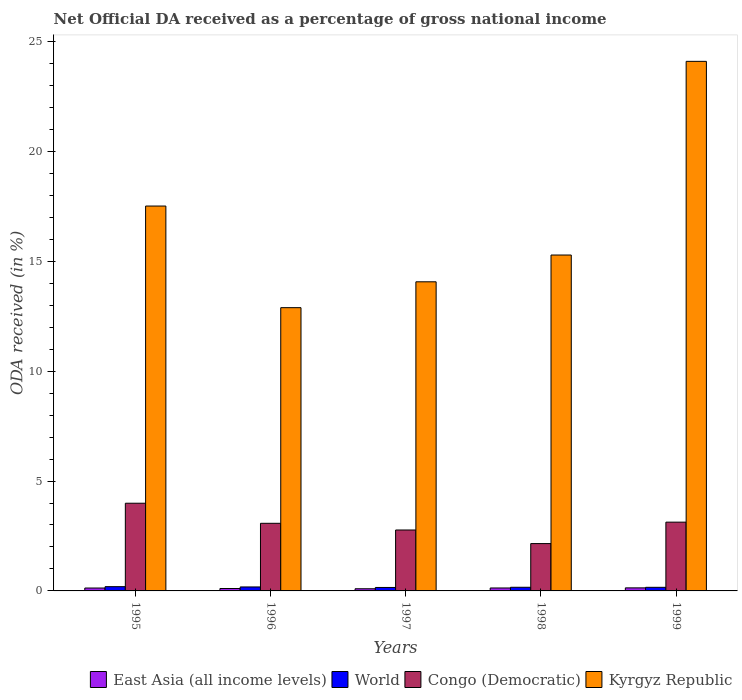How many different coloured bars are there?
Offer a terse response. 4. How many groups of bars are there?
Ensure brevity in your answer.  5. Are the number of bars per tick equal to the number of legend labels?
Your response must be concise. Yes. How many bars are there on the 4th tick from the right?
Offer a very short reply. 4. What is the label of the 3rd group of bars from the left?
Ensure brevity in your answer.  1997. In how many cases, is the number of bars for a given year not equal to the number of legend labels?
Give a very brief answer. 0. What is the net official DA received in Kyrgyz Republic in 1995?
Make the answer very short. 17.51. Across all years, what is the maximum net official DA received in Kyrgyz Republic?
Offer a very short reply. 24.09. Across all years, what is the minimum net official DA received in Congo (Democratic)?
Ensure brevity in your answer.  2.15. In which year was the net official DA received in Kyrgyz Republic maximum?
Provide a short and direct response. 1999. In which year was the net official DA received in Kyrgyz Republic minimum?
Make the answer very short. 1996. What is the total net official DA received in Kyrgyz Republic in the graph?
Offer a very short reply. 83.84. What is the difference between the net official DA received in Congo (Democratic) in 1995 and that in 1996?
Your answer should be compact. 0.91. What is the difference between the net official DA received in World in 1997 and the net official DA received in East Asia (all income levels) in 1999?
Offer a very short reply. 0.02. What is the average net official DA received in East Asia (all income levels) per year?
Your answer should be very brief. 0.12. In the year 1995, what is the difference between the net official DA received in World and net official DA received in Congo (Democratic)?
Offer a very short reply. -3.8. In how many years, is the net official DA received in Kyrgyz Republic greater than 5 %?
Ensure brevity in your answer.  5. What is the ratio of the net official DA received in East Asia (all income levels) in 1998 to that in 1999?
Offer a very short reply. 0.96. What is the difference between the highest and the second highest net official DA received in Congo (Democratic)?
Provide a short and direct response. 0.86. What is the difference between the highest and the lowest net official DA received in World?
Your answer should be very brief. 0.04. In how many years, is the net official DA received in Congo (Democratic) greater than the average net official DA received in Congo (Democratic) taken over all years?
Give a very brief answer. 3. Is the sum of the net official DA received in Congo (Democratic) in 1998 and 1999 greater than the maximum net official DA received in Kyrgyz Republic across all years?
Offer a very short reply. No. What does the 1st bar from the left in 1999 represents?
Give a very brief answer. East Asia (all income levels). What does the 2nd bar from the right in 1998 represents?
Your answer should be compact. Congo (Democratic). Is it the case that in every year, the sum of the net official DA received in Congo (Democratic) and net official DA received in Kyrgyz Republic is greater than the net official DA received in World?
Offer a very short reply. Yes. How many bars are there?
Offer a terse response. 20. How many years are there in the graph?
Your response must be concise. 5. Does the graph contain any zero values?
Make the answer very short. No. How many legend labels are there?
Keep it short and to the point. 4. How are the legend labels stacked?
Your answer should be very brief. Horizontal. What is the title of the graph?
Provide a short and direct response. Net Official DA received as a percentage of gross national income. Does "Liechtenstein" appear as one of the legend labels in the graph?
Your response must be concise. No. What is the label or title of the X-axis?
Keep it short and to the point. Years. What is the label or title of the Y-axis?
Provide a short and direct response. ODA received (in %). What is the ODA received (in %) of East Asia (all income levels) in 1995?
Give a very brief answer. 0.13. What is the ODA received (in %) of World in 1995?
Give a very brief answer. 0.19. What is the ODA received (in %) of Congo (Democratic) in 1995?
Give a very brief answer. 3.99. What is the ODA received (in %) of Kyrgyz Republic in 1995?
Your response must be concise. 17.51. What is the ODA received (in %) of East Asia (all income levels) in 1996?
Make the answer very short. 0.11. What is the ODA received (in %) of World in 1996?
Provide a short and direct response. 0.18. What is the ODA received (in %) in Congo (Democratic) in 1996?
Offer a very short reply. 3.08. What is the ODA received (in %) of Kyrgyz Republic in 1996?
Ensure brevity in your answer.  12.89. What is the ODA received (in %) of East Asia (all income levels) in 1997?
Your answer should be compact. 0.1. What is the ODA received (in %) of World in 1997?
Your answer should be compact. 0.16. What is the ODA received (in %) of Congo (Democratic) in 1997?
Your response must be concise. 2.77. What is the ODA received (in %) of Kyrgyz Republic in 1997?
Provide a short and direct response. 14.06. What is the ODA received (in %) in East Asia (all income levels) in 1998?
Make the answer very short. 0.13. What is the ODA received (in %) in World in 1998?
Give a very brief answer. 0.17. What is the ODA received (in %) in Congo (Democratic) in 1998?
Provide a short and direct response. 2.15. What is the ODA received (in %) of Kyrgyz Republic in 1998?
Keep it short and to the point. 15.28. What is the ODA received (in %) of East Asia (all income levels) in 1999?
Give a very brief answer. 0.14. What is the ODA received (in %) of World in 1999?
Your answer should be compact. 0.16. What is the ODA received (in %) of Congo (Democratic) in 1999?
Your answer should be very brief. 3.13. What is the ODA received (in %) of Kyrgyz Republic in 1999?
Your response must be concise. 24.09. Across all years, what is the maximum ODA received (in %) in East Asia (all income levels)?
Give a very brief answer. 0.14. Across all years, what is the maximum ODA received (in %) in World?
Your answer should be very brief. 0.19. Across all years, what is the maximum ODA received (in %) of Congo (Democratic)?
Provide a succinct answer. 3.99. Across all years, what is the maximum ODA received (in %) in Kyrgyz Republic?
Provide a succinct answer. 24.09. Across all years, what is the minimum ODA received (in %) of East Asia (all income levels)?
Offer a very short reply. 0.1. Across all years, what is the minimum ODA received (in %) in World?
Ensure brevity in your answer.  0.16. Across all years, what is the minimum ODA received (in %) of Congo (Democratic)?
Your answer should be very brief. 2.15. Across all years, what is the minimum ODA received (in %) of Kyrgyz Republic?
Your answer should be compact. 12.89. What is the total ODA received (in %) in East Asia (all income levels) in the graph?
Keep it short and to the point. 0.61. What is the total ODA received (in %) of World in the graph?
Provide a succinct answer. 0.86. What is the total ODA received (in %) in Congo (Democratic) in the graph?
Ensure brevity in your answer.  15.12. What is the total ODA received (in %) of Kyrgyz Republic in the graph?
Make the answer very short. 83.84. What is the difference between the ODA received (in %) in East Asia (all income levels) in 1995 and that in 1996?
Your answer should be very brief. 0.02. What is the difference between the ODA received (in %) of World in 1995 and that in 1996?
Give a very brief answer. 0.01. What is the difference between the ODA received (in %) in Congo (Democratic) in 1995 and that in 1996?
Ensure brevity in your answer.  0.91. What is the difference between the ODA received (in %) of Kyrgyz Republic in 1995 and that in 1996?
Offer a terse response. 4.62. What is the difference between the ODA received (in %) in East Asia (all income levels) in 1995 and that in 1997?
Your answer should be compact. 0.03. What is the difference between the ODA received (in %) of World in 1995 and that in 1997?
Give a very brief answer. 0.04. What is the difference between the ODA received (in %) in Congo (Democratic) in 1995 and that in 1997?
Offer a terse response. 1.22. What is the difference between the ODA received (in %) of Kyrgyz Republic in 1995 and that in 1997?
Provide a succinct answer. 3.45. What is the difference between the ODA received (in %) of East Asia (all income levels) in 1995 and that in 1998?
Provide a succinct answer. -0. What is the difference between the ODA received (in %) of World in 1995 and that in 1998?
Ensure brevity in your answer.  0.03. What is the difference between the ODA received (in %) in Congo (Democratic) in 1995 and that in 1998?
Your answer should be compact. 1.84. What is the difference between the ODA received (in %) of Kyrgyz Republic in 1995 and that in 1998?
Make the answer very short. 2.23. What is the difference between the ODA received (in %) in East Asia (all income levels) in 1995 and that in 1999?
Offer a terse response. -0.01. What is the difference between the ODA received (in %) in World in 1995 and that in 1999?
Ensure brevity in your answer.  0.03. What is the difference between the ODA received (in %) in Congo (Democratic) in 1995 and that in 1999?
Provide a short and direct response. 0.86. What is the difference between the ODA received (in %) in Kyrgyz Republic in 1995 and that in 1999?
Offer a terse response. -6.58. What is the difference between the ODA received (in %) of East Asia (all income levels) in 1996 and that in 1997?
Your answer should be compact. 0.01. What is the difference between the ODA received (in %) in World in 1996 and that in 1997?
Your response must be concise. 0.02. What is the difference between the ODA received (in %) of Congo (Democratic) in 1996 and that in 1997?
Offer a very short reply. 0.3. What is the difference between the ODA received (in %) in Kyrgyz Republic in 1996 and that in 1997?
Provide a short and direct response. -1.18. What is the difference between the ODA received (in %) in East Asia (all income levels) in 1996 and that in 1998?
Your answer should be very brief. -0.02. What is the difference between the ODA received (in %) in World in 1996 and that in 1998?
Ensure brevity in your answer.  0.01. What is the difference between the ODA received (in %) in Congo (Democratic) in 1996 and that in 1998?
Offer a very short reply. 0.92. What is the difference between the ODA received (in %) of Kyrgyz Republic in 1996 and that in 1998?
Give a very brief answer. -2.4. What is the difference between the ODA received (in %) of East Asia (all income levels) in 1996 and that in 1999?
Your response must be concise. -0.03. What is the difference between the ODA received (in %) of World in 1996 and that in 1999?
Your answer should be compact. 0.02. What is the difference between the ODA received (in %) of Congo (Democratic) in 1996 and that in 1999?
Provide a short and direct response. -0.05. What is the difference between the ODA received (in %) of Kyrgyz Republic in 1996 and that in 1999?
Provide a succinct answer. -11.21. What is the difference between the ODA received (in %) of East Asia (all income levels) in 1997 and that in 1998?
Your answer should be compact. -0.04. What is the difference between the ODA received (in %) in World in 1997 and that in 1998?
Keep it short and to the point. -0.01. What is the difference between the ODA received (in %) of Congo (Democratic) in 1997 and that in 1998?
Give a very brief answer. 0.62. What is the difference between the ODA received (in %) in Kyrgyz Republic in 1997 and that in 1998?
Your answer should be very brief. -1.22. What is the difference between the ODA received (in %) of East Asia (all income levels) in 1997 and that in 1999?
Make the answer very short. -0.04. What is the difference between the ODA received (in %) in World in 1997 and that in 1999?
Give a very brief answer. -0.01. What is the difference between the ODA received (in %) in Congo (Democratic) in 1997 and that in 1999?
Ensure brevity in your answer.  -0.36. What is the difference between the ODA received (in %) in Kyrgyz Republic in 1997 and that in 1999?
Your response must be concise. -10.03. What is the difference between the ODA received (in %) of East Asia (all income levels) in 1998 and that in 1999?
Your answer should be compact. -0.01. What is the difference between the ODA received (in %) of World in 1998 and that in 1999?
Ensure brevity in your answer.  0. What is the difference between the ODA received (in %) of Congo (Democratic) in 1998 and that in 1999?
Offer a very short reply. -0.98. What is the difference between the ODA received (in %) in Kyrgyz Republic in 1998 and that in 1999?
Give a very brief answer. -8.81. What is the difference between the ODA received (in %) of East Asia (all income levels) in 1995 and the ODA received (in %) of World in 1996?
Your answer should be very brief. -0.05. What is the difference between the ODA received (in %) in East Asia (all income levels) in 1995 and the ODA received (in %) in Congo (Democratic) in 1996?
Ensure brevity in your answer.  -2.94. What is the difference between the ODA received (in %) of East Asia (all income levels) in 1995 and the ODA received (in %) of Kyrgyz Republic in 1996?
Offer a very short reply. -12.76. What is the difference between the ODA received (in %) of World in 1995 and the ODA received (in %) of Congo (Democratic) in 1996?
Offer a terse response. -2.88. What is the difference between the ODA received (in %) of World in 1995 and the ODA received (in %) of Kyrgyz Republic in 1996?
Offer a terse response. -12.69. What is the difference between the ODA received (in %) in Congo (Democratic) in 1995 and the ODA received (in %) in Kyrgyz Republic in 1996?
Give a very brief answer. -8.9. What is the difference between the ODA received (in %) of East Asia (all income levels) in 1995 and the ODA received (in %) of World in 1997?
Ensure brevity in your answer.  -0.03. What is the difference between the ODA received (in %) in East Asia (all income levels) in 1995 and the ODA received (in %) in Congo (Democratic) in 1997?
Your answer should be compact. -2.64. What is the difference between the ODA received (in %) of East Asia (all income levels) in 1995 and the ODA received (in %) of Kyrgyz Republic in 1997?
Ensure brevity in your answer.  -13.93. What is the difference between the ODA received (in %) in World in 1995 and the ODA received (in %) in Congo (Democratic) in 1997?
Offer a terse response. -2.58. What is the difference between the ODA received (in %) in World in 1995 and the ODA received (in %) in Kyrgyz Republic in 1997?
Your answer should be very brief. -13.87. What is the difference between the ODA received (in %) of Congo (Democratic) in 1995 and the ODA received (in %) of Kyrgyz Republic in 1997?
Your answer should be very brief. -10.07. What is the difference between the ODA received (in %) of East Asia (all income levels) in 1995 and the ODA received (in %) of World in 1998?
Make the answer very short. -0.03. What is the difference between the ODA received (in %) of East Asia (all income levels) in 1995 and the ODA received (in %) of Congo (Democratic) in 1998?
Offer a terse response. -2.02. What is the difference between the ODA received (in %) of East Asia (all income levels) in 1995 and the ODA received (in %) of Kyrgyz Republic in 1998?
Your answer should be compact. -15.15. What is the difference between the ODA received (in %) in World in 1995 and the ODA received (in %) in Congo (Democratic) in 1998?
Ensure brevity in your answer.  -1.96. What is the difference between the ODA received (in %) in World in 1995 and the ODA received (in %) in Kyrgyz Republic in 1998?
Offer a terse response. -15.09. What is the difference between the ODA received (in %) in Congo (Democratic) in 1995 and the ODA received (in %) in Kyrgyz Republic in 1998?
Ensure brevity in your answer.  -11.29. What is the difference between the ODA received (in %) in East Asia (all income levels) in 1995 and the ODA received (in %) in World in 1999?
Offer a terse response. -0.03. What is the difference between the ODA received (in %) of East Asia (all income levels) in 1995 and the ODA received (in %) of Congo (Democratic) in 1999?
Offer a terse response. -3. What is the difference between the ODA received (in %) of East Asia (all income levels) in 1995 and the ODA received (in %) of Kyrgyz Republic in 1999?
Your answer should be very brief. -23.96. What is the difference between the ODA received (in %) in World in 1995 and the ODA received (in %) in Congo (Democratic) in 1999?
Your answer should be compact. -2.94. What is the difference between the ODA received (in %) of World in 1995 and the ODA received (in %) of Kyrgyz Republic in 1999?
Provide a succinct answer. -23.9. What is the difference between the ODA received (in %) in Congo (Democratic) in 1995 and the ODA received (in %) in Kyrgyz Republic in 1999?
Offer a very short reply. -20.1. What is the difference between the ODA received (in %) in East Asia (all income levels) in 1996 and the ODA received (in %) in World in 1997?
Give a very brief answer. -0.05. What is the difference between the ODA received (in %) of East Asia (all income levels) in 1996 and the ODA received (in %) of Congo (Democratic) in 1997?
Your response must be concise. -2.66. What is the difference between the ODA received (in %) of East Asia (all income levels) in 1996 and the ODA received (in %) of Kyrgyz Republic in 1997?
Provide a succinct answer. -13.95. What is the difference between the ODA received (in %) of World in 1996 and the ODA received (in %) of Congo (Democratic) in 1997?
Offer a terse response. -2.59. What is the difference between the ODA received (in %) of World in 1996 and the ODA received (in %) of Kyrgyz Republic in 1997?
Keep it short and to the point. -13.88. What is the difference between the ODA received (in %) of Congo (Democratic) in 1996 and the ODA received (in %) of Kyrgyz Republic in 1997?
Provide a succinct answer. -10.99. What is the difference between the ODA received (in %) of East Asia (all income levels) in 1996 and the ODA received (in %) of World in 1998?
Offer a terse response. -0.06. What is the difference between the ODA received (in %) of East Asia (all income levels) in 1996 and the ODA received (in %) of Congo (Democratic) in 1998?
Offer a terse response. -2.04. What is the difference between the ODA received (in %) of East Asia (all income levels) in 1996 and the ODA received (in %) of Kyrgyz Republic in 1998?
Provide a succinct answer. -15.17. What is the difference between the ODA received (in %) in World in 1996 and the ODA received (in %) in Congo (Democratic) in 1998?
Keep it short and to the point. -1.97. What is the difference between the ODA received (in %) of World in 1996 and the ODA received (in %) of Kyrgyz Republic in 1998?
Ensure brevity in your answer.  -15.1. What is the difference between the ODA received (in %) in Congo (Democratic) in 1996 and the ODA received (in %) in Kyrgyz Republic in 1998?
Give a very brief answer. -12.21. What is the difference between the ODA received (in %) in East Asia (all income levels) in 1996 and the ODA received (in %) in World in 1999?
Make the answer very short. -0.05. What is the difference between the ODA received (in %) of East Asia (all income levels) in 1996 and the ODA received (in %) of Congo (Democratic) in 1999?
Keep it short and to the point. -3.02. What is the difference between the ODA received (in %) in East Asia (all income levels) in 1996 and the ODA received (in %) in Kyrgyz Republic in 1999?
Provide a short and direct response. -23.98. What is the difference between the ODA received (in %) of World in 1996 and the ODA received (in %) of Congo (Democratic) in 1999?
Provide a short and direct response. -2.95. What is the difference between the ODA received (in %) in World in 1996 and the ODA received (in %) in Kyrgyz Republic in 1999?
Offer a terse response. -23.91. What is the difference between the ODA received (in %) of Congo (Democratic) in 1996 and the ODA received (in %) of Kyrgyz Republic in 1999?
Provide a short and direct response. -21.02. What is the difference between the ODA received (in %) of East Asia (all income levels) in 1997 and the ODA received (in %) of World in 1998?
Your answer should be compact. -0.07. What is the difference between the ODA received (in %) in East Asia (all income levels) in 1997 and the ODA received (in %) in Congo (Democratic) in 1998?
Make the answer very short. -2.06. What is the difference between the ODA received (in %) in East Asia (all income levels) in 1997 and the ODA received (in %) in Kyrgyz Republic in 1998?
Give a very brief answer. -15.18. What is the difference between the ODA received (in %) of World in 1997 and the ODA received (in %) of Congo (Democratic) in 1998?
Your answer should be very brief. -2. What is the difference between the ODA received (in %) in World in 1997 and the ODA received (in %) in Kyrgyz Republic in 1998?
Keep it short and to the point. -15.13. What is the difference between the ODA received (in %) of Congo (Democratic) in 1997 and the ODA received (in %) of Kyrgyz Republic in 1998?
Keep it short and to the point. -12.51. What is the difference between the ODA received (in %) of East Asia (all income levels) in 1997 and the ODA received (in %) of World in 1999?
Ensure brevity in your answer.  -0.07. What is the difference between the ODA received (in %) of East Asia (all income levels) in 1997 and the ODA received (in %) of Congo (Democratic) in 1999?
Offer a terse response. -3.03. What is the difference between the ODA received (in %) of East Asia (all income levels) in 1997 and the ODA received (in %) of Kyrgyz Republic in 1999?
Your response must be concise. -24. What is the difference between the ODA received (in %) in World in 1997 and the ODA received (in %) in Congo (Democratic) in 1999?
Ensure brevity in your answer.  -2.97. What is the difference between the ODA received (in %) in World in 1997 and the ODA received (in %) in Kyrgyz Republic in 1999?
Ensure brevity in your answer.  -23.94. What is the difference between the ODA received (in %) in Congo (Democratic) in 1997 and the ODA received (in %) in Kyrgyz Republic in 1999?
Your response must be concise. -21.32. What is the difference between the ODA received (in %) of East Asia (all income levels) in 1998 and the ODA received (in %) of World in 1999?
Your answer should be very brief. -0.03. What is the difference between the ODA received (in %) in East Asia (all income levels) in 1998 and the ODA received (in %) in Congo (Democratic) in 1999?
Your answer should be compact. -3. What is the difference between the ODA received (in %) in East Asia (all income levels) in 1998 and the ODA received (in %) in Kyrgyz Republic in 1999?
Your answer should be very brief. -23.96. What is the difference between the ODA received (in %) in World in 1998 and the ODA received (in %) in Congo (Democratic) in 1999?
Provide a short and direct response. -2.96. What is the difference between the ODA received (in %) of World in 1998 and the ODA received (in %) of Kyrgyz Republic in 1999?
Your answer should be very brief. -23.93. What is the difference between the ODA received (in %) of Congo (Democratic) in 1998 and the ODA received (in %) of Kyrgyz Republic in 1999?
Your answer should be very brief. -21.94. What is the average ODA received (in %) of East Asia (all income levels) per year?
Ensure brevity in your answer.  0.12. What is the average ODA received (in %) of World per year?
Keep it short and to the point. 0.17. What is the average ODA received (in %) of Congo (Democratic) per year?
Provide a succinct answer. 3.02. What is the average ODA received (in %) of Kyrgyz Republic per year?
Offer a terse response. 16.77. In the year 1995, what is the difference between the ODA received (in %) of East Asia (all income levels) and ODA received (in %) of World?
Offer a very short reply. -0.06. In the year 1995, what is the difference between the ODA received (in %) of East Asia (all income levels) and ODA received (in %) of Congo (Democratic)?
Your answer should be compact. -3.86. In the year 1995, what is the difference between the ODA received (in %) of East Asia (all income levels) and ODA received (in %) of Kyrgyz Republic?
Give a very brief answer. -17.38. In the year 1995, what is the difference between the ODA received (in %) of World and ODA received (in %) of Congo (Democratic)?
Offer a terse response. -3.8. In the year 1995, what is the difference between the ODA received (in %) of World and ODA received (in %) of Kyrgyz Republic?
Keep it short and to the point. -17.32. In the year 1995, what is the difference between the ODA received (in %) of Congo (Democratic) and ODA received (in %) of Kyrgyz Republic?
Offer a terse response. -13.52. In the year 1996, what is the difference between the ODA received (in %) in East Asia (all income levels) and ODA received (in %) in World?
Keep it short and to the point. -0.07. In the year 1996, what is the difference between the ODA received (in %) of East Asia (all income levels) and ODA received (in %) of Congo (Democratic)?
Your answer should be very brief. -2.97. In the year 1996, what is the difference between the ODA received (in %) in East Asia (all income levels) and ODA received (in %) in Kyrgyz Republic?
Provide a short and direct response. -12.78. In the year 1996, what is the difference between the ODA received (in %) of World and ODA received (in %) of Congo (Democratic)?
Your answer should be very brief. -2.9. In the year 1996, what is the difference between the ODA received (in %) in World and ODA received (in %) in Kyrgyz Republic?
Keep it short and to the point. -12.71. In the year 1996, what is the difference between the ODA received (in %) in Congo (Democratic) and ODA received (in %) in Kyrgyz Republic?
Your answer should be compact. -9.81. In the year 1997, what is the difference between the ODA received (in %) in East Asia (all income levels) and ODA received (in %) in World?
Ensure brevity in your answer.  -0.06. In the year 1997, what is the difference between the ODA received (in %) of East Asia (all income levels) and ODA received (in %) of Congo (Democratic)?
Provide a succinct answer. -2.67. In the year 1997, what is the difference between the ODA received (in %) in East Asia (all income levels) and ODA received (in %) in Kyrgyz Republic?
Offer a terse response. -13.97. In the year 1997, what is the difference between the ODA received (in %) of World and ODA received (in %) of Congo (Democratic)?
Offer a very short reply. -2.62. In the year 1997, what is the difference between the ODA received (in %) in World and ODA received (in %) in Kyrgyz Republic?
Give a very brief answer. -13.91. In the year 1997, what is the difference between the ODA received (in %) in Congo (Democratic) and ODA received (in %) in Kyrgyz Republic?
Your response must be concise. -11.29. In the year 1998, what is the difference between the ODA received (in %) of East Asia (all income levels) and ODA received (in %) of World?
Your answer should be compact. -0.03. In the year 1998, what is the difference between the ODA received (in %) of East Asia (all income levels) and ODA received (in %) of Congo (Democratic)?
Your response must be concise. -2.02. In the year 1998, what is the difference between the ODA received (in %) in East Asia (all income levels) and ODA received (in %) in Kyrgyz Republic?
Make the answer very short. -15.15. In the year 1998, what is the difference between the ODA received (in %) of World and ODA received (in %) of Congo (Democratic)?
Make the answer very short. -1.99. In the year 1998, what is the difference between the ODA received (in %) in World and ODA received (in %) in Kyrgyz Republic?
Your answer should be compact. -15.12. In the year 1998, what is the difference between the ODA received (in %) of Congo (Democratic) and ODA received (in %) of Kyrgyz Republic?
Make the answer very short. -13.13. In the year 1999, what is the difference between the ODA received (in %) in East Asia (all income levels) and ODA received (in %) in World?
Make the answer very short. -0.03. In the year 1999, what is the difference between the ODA received (in %) of East Asia (all income levels) and ODA received (in %) of Congo (Democratic)?
Keep it short and to the point. -2.99. In the year 1999, what is the difference between the ODA received (in %) of East Asia (all income levels) and ODA received (in %) of Kyrgyz Republic?
Your response must be concise. -23.96. In the year 1999, what is the difference between the ODA received (in %) of World and ODA received (in %) of Congo (Democratic)?
Keep it short and to the point. -2.96. In the year 1999, what is the difference between the ODA received (in %) of World and ODA received (in %) of Kyrgyz Republic?
Provide a succinct answer. -23.93. In the year 1999, what is the difference between the ODA received (in %) of Congo (Democratic) and ODA received (in %) of Kyrgyz Republic?
Provide a succinct answer. -20.97. What is the ratio of the ODA received (in %) of East Asia (all income levels) in 1995 to that in 1996?
Offer a very short reply. 1.2. What is the ratio of the ODA received (in %) in World in 1995 to that in 1996?
Offer a terse response. 1.07. What is the ratio of the ODA received (in %) in Congo (Democratic) in 1995 to that in 1996?
Your answer should be very brief. 1.3. What is the ratio of the ODA received (in %) in Kyrgyz Republic in 1995 to that in 1996?
Offer a very short reply. 1.36. What is the ratio of the ODA received (in %) in East Asia (all income levels) in 1995 to that in 1997?
Provide a succinct answer. 1.34. What is the ratio of the ODA received (in %) of World in 1995 to that in 1997?
Keep it short and to the point. 1.23. What is the ratio of the ODA received (in %) of Congo (Democratic) in 1995 to that in 1997?
Make the answer very short. 1.44. What is the ratio of the ODA received (in %) in Kyrgyz Republic in 1995 to that in 1997?
Offer a very short reply. 1.25. What is the ratio of the ODA received (in %) of East Asia (all income levels) in 1995 to that in 1998?
Offer a terse response. 0.98. What is the ratio of the ODA received (in %) of World in 1995 to that in 1998?
Give a very brief answer. 1.17. What is the ratio of the ODA received (in %) of Congo (Democratic) in 1995 to that in 1998?
Give a very brief answer. 1.85. What is the ratio of the ODA received (in %) of Kyrgyz Republic in 1995 to that in 1998?
Your response must be concise. 1.15. What is the ratio of the ODA received (in %) of East Asia (all income levels) in 1995 to that in 1999?
Provide a short and direct response. 0.95. What is the ratio of the ODA received (in %) in World in 1995 to that in 1999?
Provide a succinct answer. 1.18. What is the ratio of the ODA received (in %) of Congo (Democratic) in 1995 to that in 1999?
Keep it short and to the point. 1.28. What is the ratio of the ODA received (in %) in Kyrgyz Republic in 1995 to that in 1999?
Your response must be concise. 0.73. What is the ratio of the ODA received (in %) in East Asia (all income levels) in 1996 to that in 1997?
Your answer should be compact. 1.11. What is the ratio of the ODA received (in %) in World in 1996 to that in 1997?
Make the answer very short. 1.15. What is the ratio of the ODA received (in %) in Congo (Democratic) in 1996 to that in 1997?
Your answer should be very brief. 1.11. What is the ratio of the ODA received (in %) in Kyrgyz Republic in 1996 to that in 1997?
Give a very brief answer. 0.92. What is the ratio of the ODA received (in %) of East Asia (all income levels) in 1996 to that in 1998?
Provide a short and direct response. 0.82. What is the ratio of the ODA received (in %) in World in 1996 to that in 1998?
Provide a short and direct response. 1.09. What is the ratio of the ODA received (in %) of Congo (Democratic) in 1996 to that in 1998?
Give a very brief answer. 1.43. What is the ratio of the ODA received (in %) in Kyrgyz Republic in 1996 to that in 1998?
Keep it short and to the point. 0.84. What is the ratio of the ODA received (in %) in East Asia (all income levels) in 1996 to that in 1999?
Keep it short and to the point. 0.79. What is the ratio of the ODA received (in %) in World in 1996 to that in 1999?
Provide a succinct answer. 1.1. What is the ratio of the ODA received (in %) of Congo (Democratic) in 1996 to that in 1999?
Offer a very short reply. 0.98. What is the ratio of the ODA received (in %) in Kyrgyz Republic in 1996 to that in 1999?
Ensure brevity in your answer.  0.53. What is the ratio of the ODA received (in %) of East Asia (all income levels) in 1997 to that in 1998?
Give a very brief answer. 0.74. What is the ratio of the ODA received (in %) of World in 1997 to that in 1998?
Make the answer very short. 0.95. What is the ratio of the ODA received (in %) of Congo (Democratic) in 1997 to that in 1998?
Your answer should be very brief. 1.29. What is the ratio of the ODA received (in %) of Kyrgyz Republic in 1997 to that in 1998?
Provide a short and direct response. 0.92. What is the ratio of the ODA received (in %) in East Asia (all income levels) in 1997 to that in 1999?
Provide a succinct answer. 0.71. What is the ratio of the ODA received (in %) in World in 1997 to that in 1999?
Your answer should be compact. 0.96. What is the ratio of the ODA received (in %) in Congo (Democratic) in 1997 to that in 1999?
Offer a very short reply. 0.89. What is the ratio of the ODA received (in %) of Kyrgyz Republic in 1997 to that in 1999?
Your answer should be compact. 0.58. What is the ratio of the ODA received (in %) in East Asia (all income levels) in 1998 to that in 1999?
Make the answer very short. 0.96. What is the ratio of the ODA received (in %) in World in 1998 to that in 1999?
Provide a succinct answer. 1.01. What is the ratio of the ODA received (in %) in Congo (Democratic) in 1998 to that in 1999?
Ensure brevity in your answer.  0.69. What is the ratio of the ODA received (in %) in Kyrgyz Republic in 1998 to that in 1999?
Give a very brief answer. 0.63. What is the difference between the highest and the second highest ODA received (in %) of East Asia (all income levels)?
Keep it short and to the point. 0.01. What is the difference between the highest and the second highest ODA received (in %) in World?
Offer a terse response. 0.01. What is the difference between the highest and the second highest ODA received (in %) in Congo (Democratic)?
Provide a short and direct response. 0.86. What is the difference between the highest and the second highest ODA received (in %) of Kyrgyz Republic?
Give a very brief answer. 6.58. What is the difference between the highest and the lowest ODA received (in %) in East Asia (all income levels)?
Offer a terse response. 0.04. What is the difference between the highest and the lowest ODA received (in %) in World?
Offer a terse response. 0.04. What is the difference between the highest and the lowest ODA received (in %) in Congo (Democratic)?
Your answer should be compact. 1.84. What is the difference between the highest and the lowest ODA received (in %) in Kyrgyz Republic?
Make the answer very short. 11.21. 